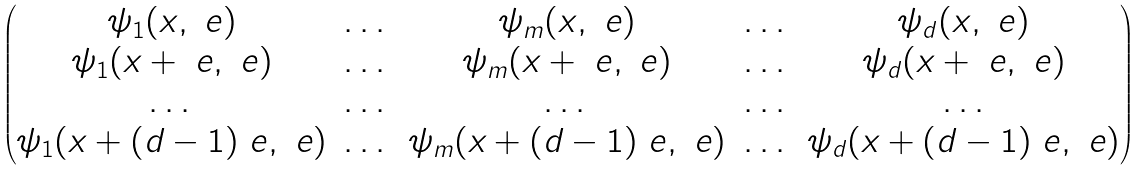<formula> <loc_0><loc_0><loc_500><loc_500>\begin{pmatrix} \psi _ { 1 } ( x , \ e ) & \dots & \psi _ { m } ( x , \ e ) & \dots & \psi _ { d } ( x , \ e ) \\ \psi _ { 1 } ( x + \ e , \ e ) & \dots & \psi _ { m } ( x + \ e , \ e ) & \dots & \psi _ { d } ( x + \ e , \ e ) \\ \dots & \dots & \dots & \dots & \dots \\ \psi _ { 1 } ( x + ( d - 1 ) \ e , \ e ) & \dots & \psi _ { m } ( x + ( d - 1 ) \ e , \ e ) & \dots & \psi _ { d } ( x + ( d - 1 ) \ e , \ e ) \\ \end{pmatrix}</formula> 